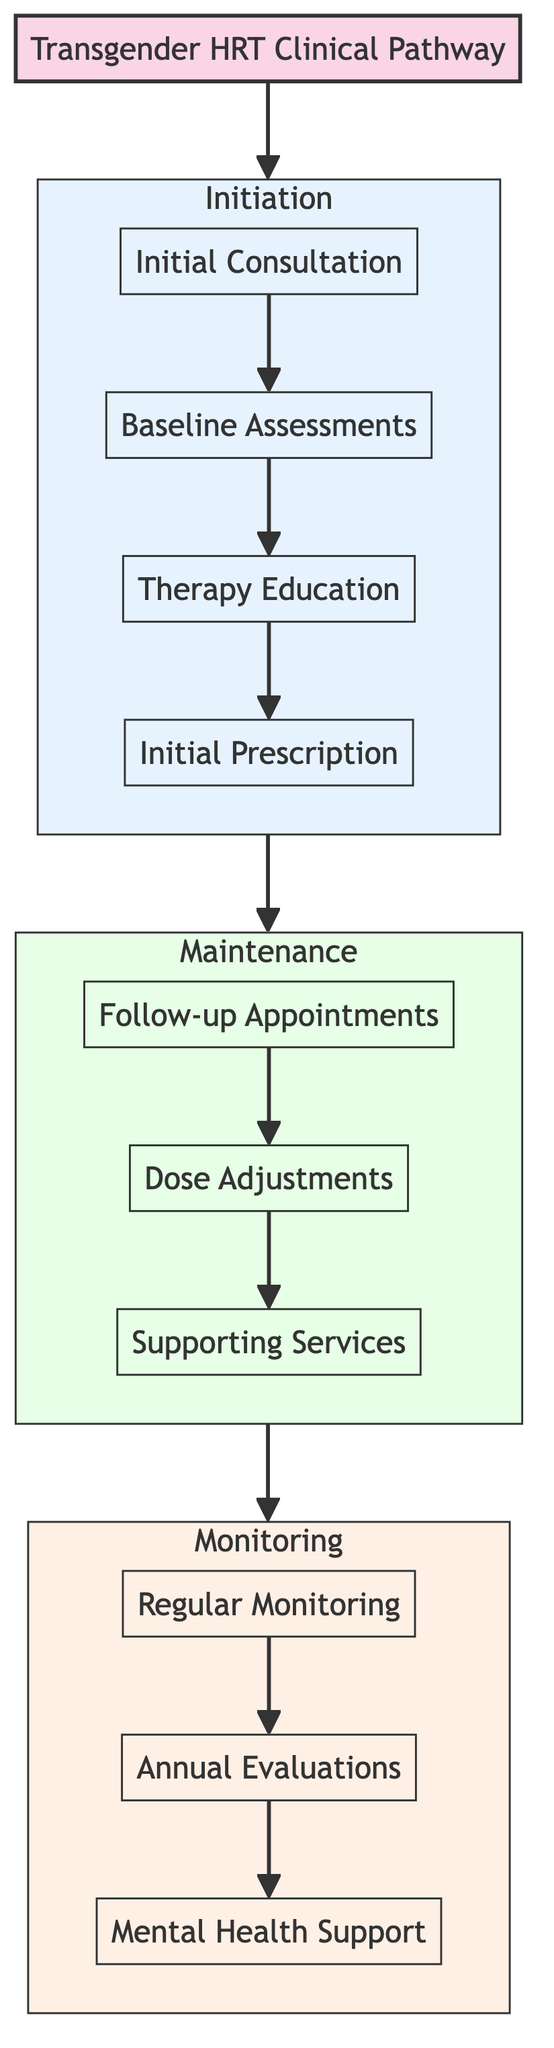What is the first step in the initiation stage? The first step listed in the initiation stage is the "Initial Consultation," which is the starting point of the clinical pathway.
Answer: Initial Consultation How many elements are in the maintenance stage? The maintenance stage contains three elements: Follow-up Appointments, Dose Adjustments, and Supporting Services.
Answer: 3 What follows the "Initial Prescription" in the initiation stage? After the "Initial Prescription," the pathway transitions to the maintenance stage. The next step is "Follow-up Appointments."
Answer: Follow-up Appointments What is the last step in the monitoring stage? The last step in the monitoring stage is "Mental Health Support."
Answer: Mental Health Support Which stage involves dose adjustments? The maintenance stage includes the element "Dose Adjustments."
Answer: Maintenance What is the common frequency for routine blood tests? Routine blood tests are scheduled every 3-6 months to monitor hormone levels and metabolic parameters.
Answer: Every 3-6 months How many total elements are in the clinical pathway? Counting all elements across the three stages, there are a total of 10 elements: four in initiation, three in maintenance, and three in monitoring.
Answer: 10 What is the second element in the monitoring stage? The second element in the monitoring stage is "Annual Evaluations," which is specifically designed for comprehensive health check-ups.
Answer: Annual Evaluations What is the purpose of "Supporting Services" in the maintenance stage? "Supporting Services" provide access to counseling, support groups, and social services to assist patients during their HRT journey.
Answer: Access to counseling, support groups, and social services 